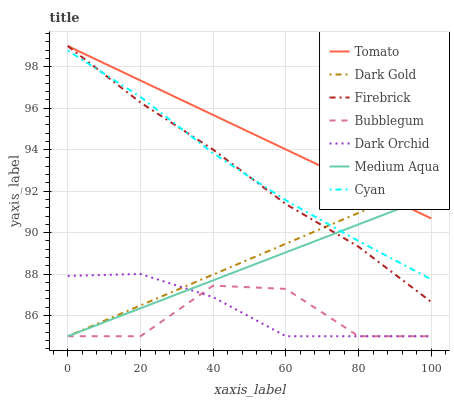Does Dark Gold have the minimum area under the curve?
Answer yes or no. No. Does Dark Gold have the maximum area under the curve?
Answer yes or no. No. Is Dark Gold the smoothest?
Answer yes or no. No. Is Dark Gold the roughest?
Answer yes or no. No. Does Firebrick have the lowest value?
Answer yes or no. No. Does Dark Gold have the highest value?
Answer yes or no. No. Is Dark Orchid less than Cyan?
Answer yes or no. Yes. Is Firebrick greater than Bubblegum?
Answer yes or no. Yes. Does Dark Orchid intersect Cyan?
Answer yes or no. No. 